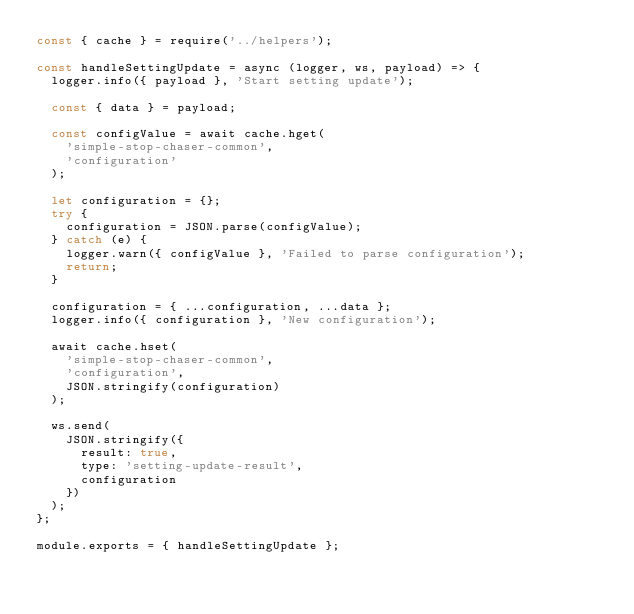<code> <loc_0><loc_0><loc_500><loc_500><_JavaScript_>const { cache } = require('../helpers');

const handleSettingUpdate = async (logger, ws, payload) => {
  logger.info({ payload }, 'Start setting update');

  const { data } = payload;

  const configValue = await cache.hget(
    'simple-stop-chaser-common',
    'configuration'
  );

  let configuration = {};
  try {
    configuration = JSON.parse(configValue);
  } catch (e) {
    logger.warn({ configValue }, 'Failed to parse configuration');
    return;
  }

  configuration = { ...configuration, ...data };
  logger.info({ configuration }, 'New configuration');

  await cache.hset(
    'simple-stop-chaser-common',
    'configuration',
    JSON.stringify(configuration)
  );

  ws.send(
    JSON.stringify({
      result: true,
      type: 'setting-update-result',
      configuration
    })
  );
};

module.exports = { handleSettingUpdate };
</code> 